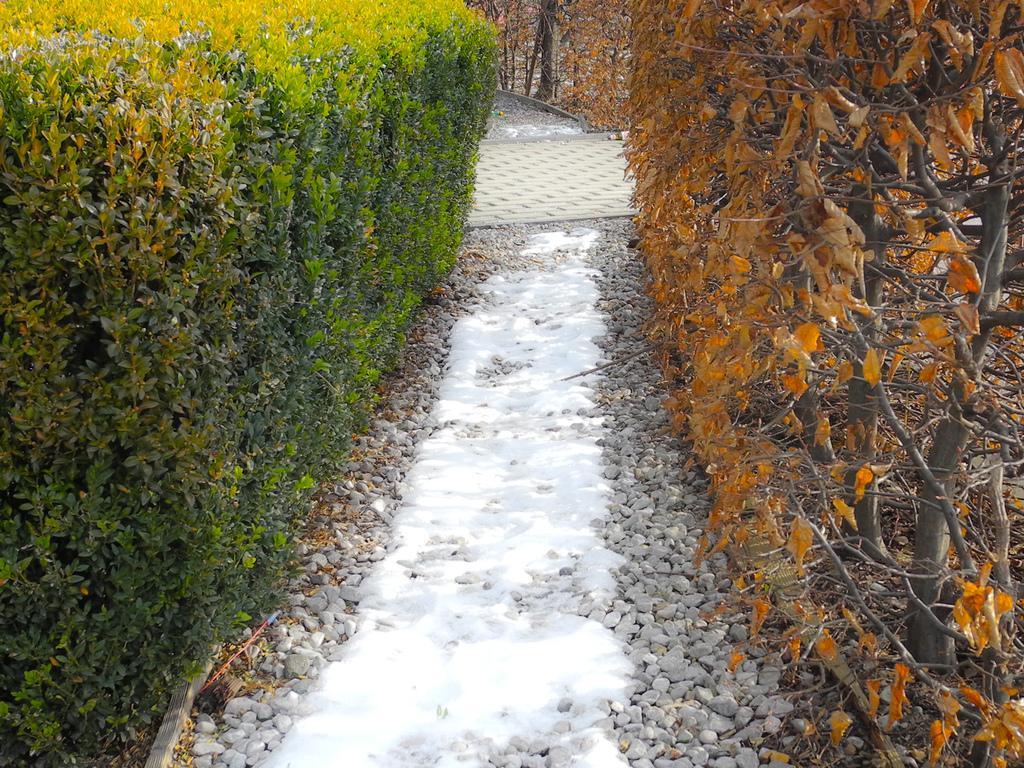Could you give a brief overview of what you see in this image? In this image we can see bushes, creepers and stones on the walking path. 